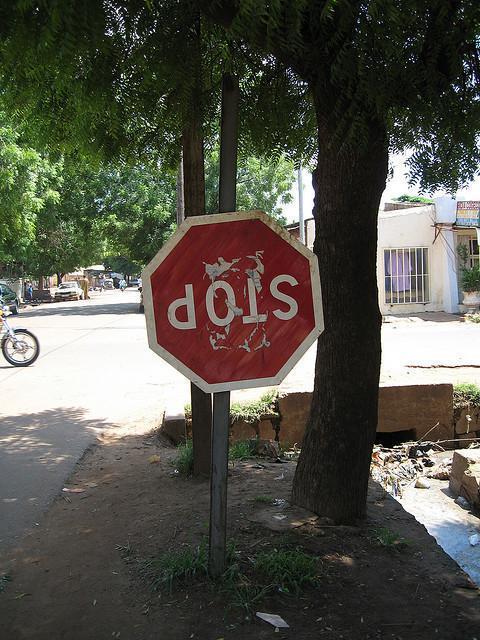How many signs?
Give a very brief answer. 1. How many people are wearing jeans?
Give a very brief answer. 0. 